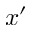Convert formula to latex. <formula><loc_0><loc_0><loc_500><loc_500>x ^ { \prime }</formula> 